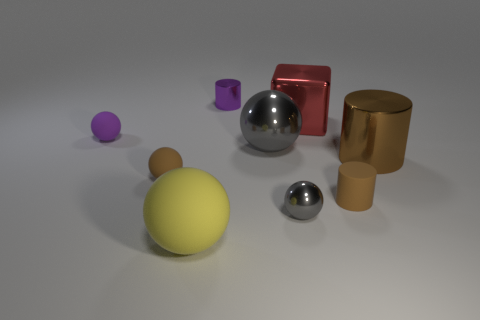There is a tiny purple thing to the left of the tiny cylinder that is to the left of the block; how many tiny purple metallic cylinders are left of it?
Give a very brief answer. 0. There is a big red block; what number of things are to the left of it?
Keep it short and to the point. 6. The large metal object that is the same shape as the purple rubber object is what color?
Your response must be concise. Gray. There is a object that is to the right of the tiny metallic sphere and behind the brown shiny thing; what material is it?
Your answer should be very brief. Metal. There is a brown matte object in front of the brown sphere; is it the same size as the red cube?
Ensure brevity in your answer.  No. What is the material of the large cylinder?
Give a very brief answer. Metal. What color is the large ball on the right side of the large yellow matte ball?
Ensure brevity in your answer.  Gray. What number of small objects are gray cylinders or gray metallic objects?
Offer a terse response. 1. Do the small cylinder right of the small gray metallic sphere and the thing behind the cube have the same color?
Provide a short and direct response. No. How many other things are there of the same color as the tiny metal cylinder?
Offer a terse response. 1. 